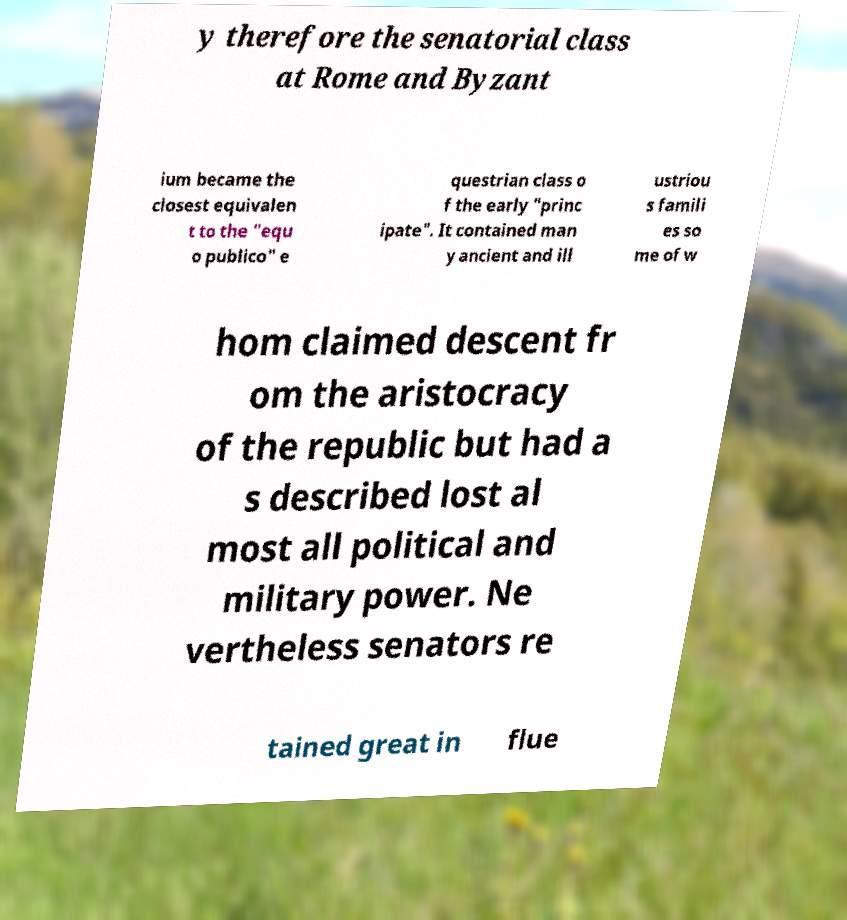Can you accurately transcribe the text from the provided image for me? y therefore the senatorial class at Rome and Byzant ium became the closest equivalen t to the "equ o publico" e questrian class o f the early "princ ipate". It contained man y ancient and ill ustriou s famili es so me of w hom claimed descent fr om the aristocracy of the republic but had a s described lost al most all political and military power. Ne vertheless senators re tained great in flue 